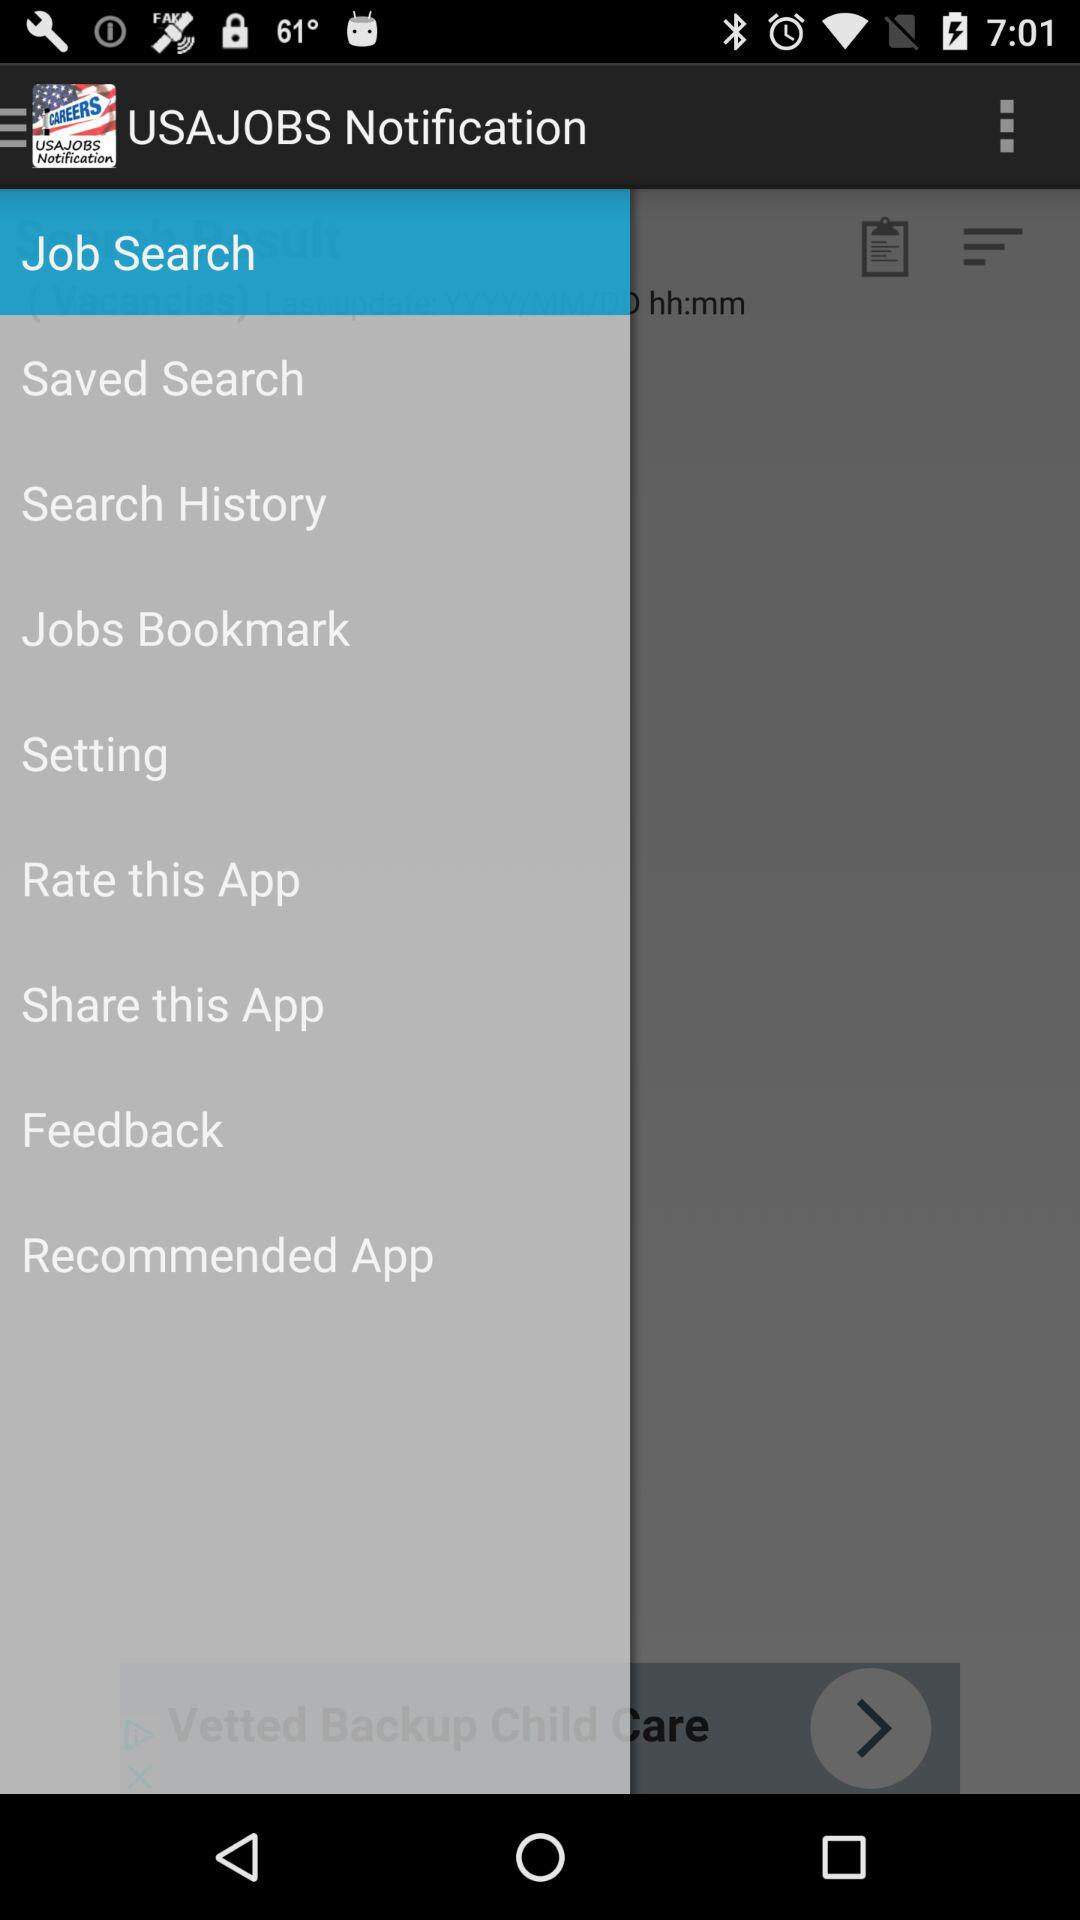What is the name of the application? The name of the application is "USAJOBS Notification". 